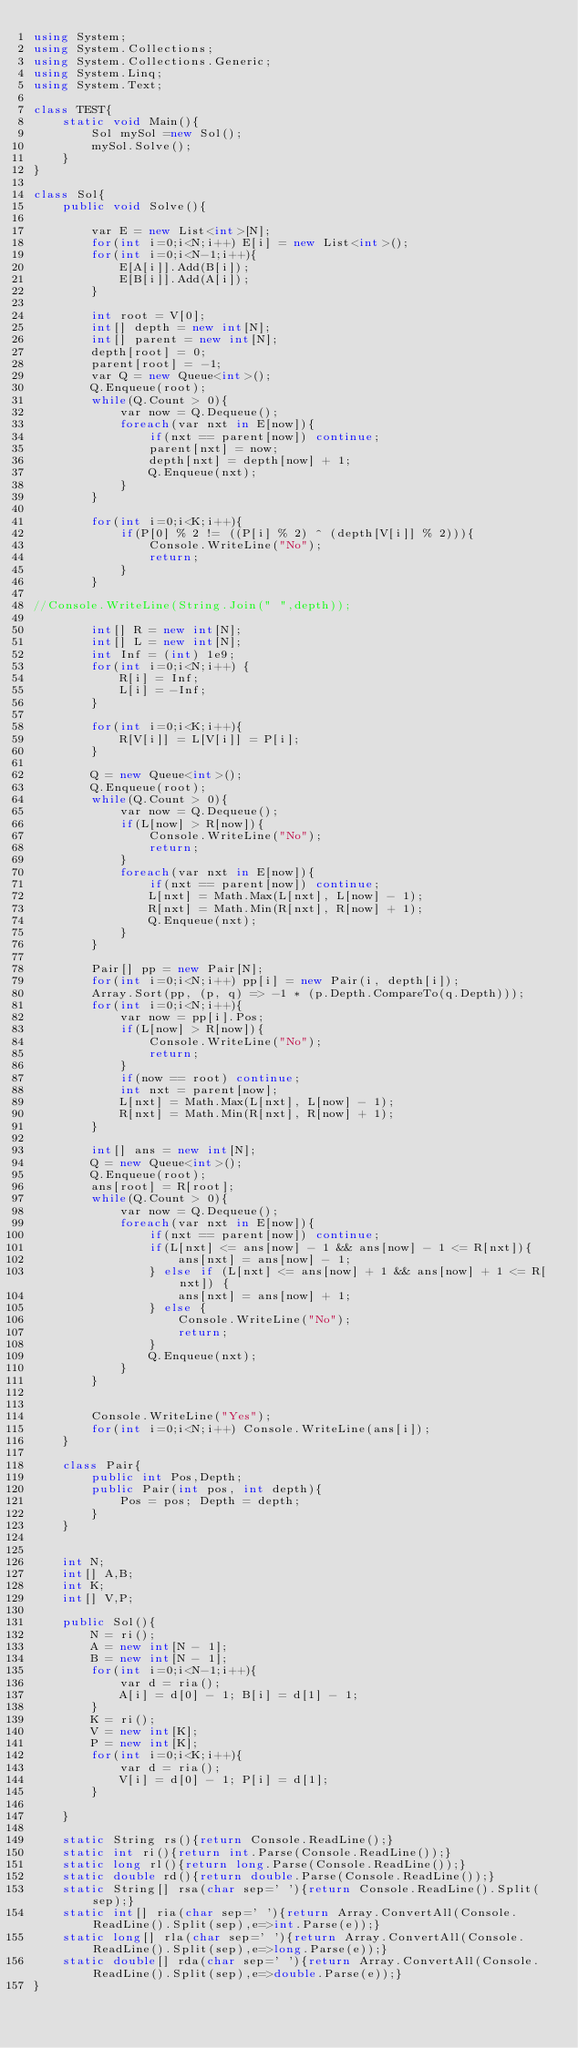Convert code to text. <code><loc_0><loc_0><loc_500><loc_500><_C#_>using System;
using System.Collections;
using System.Collections.Generic;
using System.Linq;
using System.Text;

class TEST{
	static void Main(){
		Sol mySol =new Sol();
		mySol.Solve();
	}
}

class Sol{
	public void Solve(){
		
		var E = new List<int>[N];
		for(int i=0;i<N;i++) E[i] = new List<int>();
		for(int i=0;i<N-1;i++){
			E[A[i]].Add(B[i]);
			E[B[i]].Add(A[i]);
		}
		
		int root = V[0];
		int[] depth = new int[N];
		int[] parent = new int[N];
		depth[root] = 0;
		parent[root] = -1;
		var Q = new Queue<int>();
		Q.Enqueue(root);
		while(Q.Count > 0){
			var now = Q.Dequeue();
			foreach(var nxt in E[now]){
				if(nxt == parent[now]) continue;
				parent[nxt] = now;
				depth[nxt] = depth[now] + 1;
				Q.Enqueue(nxt);
			}
		}

		for(int i=0;i<K;i++){
			if(P[0] % 2 != ((P[i] % 2) ^ (depth[V[i]] % 2))){
				Console.WriteLine("No");
				return;
			}
		}

//Console.WriteLine(String.Join(" ",depth));		
		
		int[] R = new int[N];
		int[] L = new int[N];
		int Inf = (int) 1e9;
		for(int i=0;i<N;i++) {
			R[i] = Inf;
			L[i] = -Inf;
		}
		
		for(int i=0;i<K;i++){
			R[V[i]] = L[V[i]] = P[i];
		}
		
		Q = new Queue<int>();
		Q.Enqueue(root);
		while(Q.Count > 0){
			var now = Q.Dequeue();
			if(L[now] > R[now]){
				Console.WriteLine("No");
				return;
			}
			foreach(var nxt in E[now]){
				if(nxt == parent[now]) continue;
				L[nxt] = Math.Max(L[nxt], L[now] - 1);
				R[nxt] = Math.Min(R[nxt], R[now] + 1);
				Q.Enqueue(nxt);
			}
		}
		
		Pair[] pp = new Pair[N];
		for(int i=0;i<N;i++) pp[i] = new Pair(i, depth[i]);
		Array.Sort(pp, (p, q) => -1 * (p.Depth.CompareTo(q.Depth)));
		for(int i=0;i<N;i++){
			var now = pp[i].Pos;
			if(L[now] > R[now]){
				Console.WriteLine("No");
				return;
			}
			if(now == root) continue;
			int nxt = parent[now];
			L[nxt] = Math.Max(L[nxt], L[now] - 1);
			R[nxt] = Math.Min(R[nxt], R[now] + 1);
		}
		
		int[] ans = new int[N];
		Q = new Queue<int>();
		Q.Enqueue(root);
		ans[root] = R[root];
		while(Q.Count > 0){
			var now = Q.Dequeue();
			foreach(var nxt in E[now]){
				if(nxt == parent[now]) continue;
				if(L[nxt] <= ans[now] - 1 && ans[now] - 1 <= R[nxt]){
					ans[nxt] = ans[now] - 1;
				} else if (L[nxt] <= ans[now] + 1 && ans[now] + 1 <= R[nxt]) {
					ans[nxt] = ans[now] + 1;
				} else {
					Console.WriteLine("No");
					return;
				}
				Q.Enqueue(nxt);
			}
		}
		
		
		Console.WriteLine("Yes");
		for(int i=0;i<N;i++) Console.WriteLine(ans[i]);
	}
	
	class Pair{
		public int Pos,Depth;
		public Pair(int pos, int depth){
			Pos = pos; Depth = depth;
		}
	}
	
	
	int N;
	int[] A,B;
	int K;
	int[] V,P;
	
	public Sol(){
		N = ri();
		A = new int[N - 1];
		B = new int[N - 1];
		for(int i=0;i<N-1;i++){
			var d = ria();
			A[i] = d[0] - 1; B[i] = d[1] - 1;
		}
		K = ri();
		V = new int[K];
		P = new int[K];
		for(int i=0;i<K;i++){
			var d = ria();
			V[i] = d[0] - 1; P[i] = d[1];
		}
		
	}

	static String rs(){return Console.ReadLine();}
	static int ri(){return int.Parse(Console.ReadLine());}
	static long rl(){return long.Parse(Console.ReadLine());}
	static double rd(){return double.Parse(Console.ReadLine());}
	static String[] rsa(char sep=' '){return Console.ReadLine().Split(sep);}
	static int[] ria(char sep=' '){return Array.ConvertAll(Console.ReadLine().Split(sep),e=>int.Parse(e));}
	static long[] rla(char sep=' '){return Array.ConvertAll(Console.ReadLine().Split(sep),e=>long.Parse(e));}
	static double[] rda(char sep=' '){return Array.ConvertAll(Console.ReadLine().Split(sep),e=>double.Parse(e));}
}
</code> 